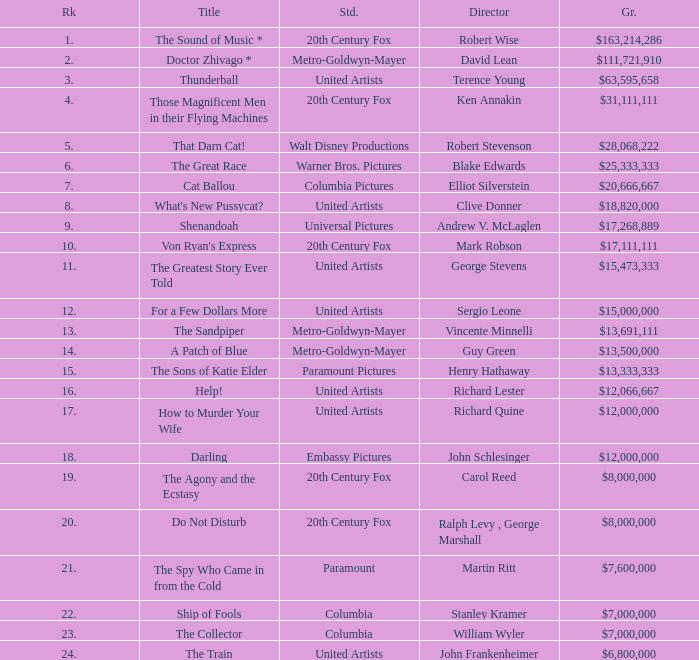What is the studio, when the name is "do not disturb"? 20th Century Fox. 